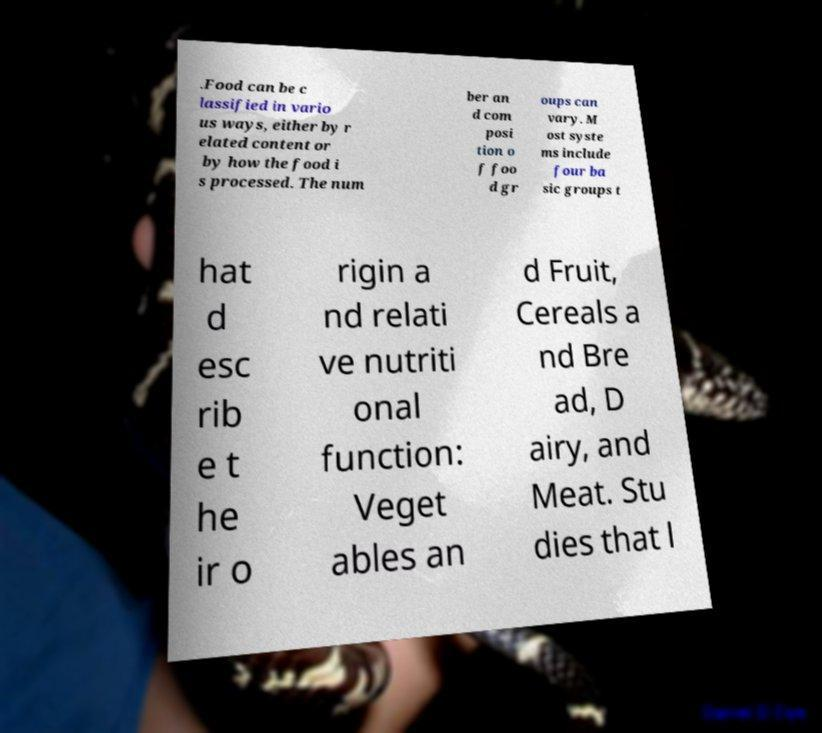There's text embedded in this image that I need extracted. Can you transcribe it verbatim? .Food can be c lassified in vario us ways, either by r elated content or by how the food i s processed. The num ber an d com posi tion o f foo d gr oups can vary. M ost syste ms include four ba sic groups t hat d esc rib e t he ir o rigin a nd relati ve nutriti onal function: Veget ables an d Fruit, Cereals a nd Bre ad, D airy, and Meat. Stu dies that l 